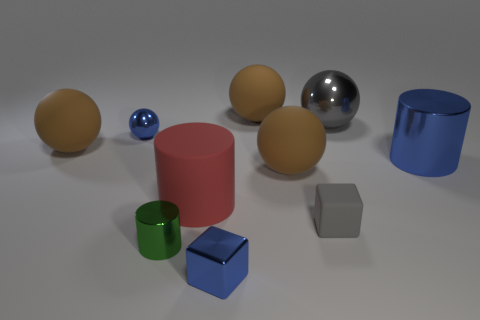There is a large cylinder in front of the cylinder that is to the right of the tiny gray rubber block; is there a large thing that is behind it?
Your answer should be very brief. Yes. What material is the green object?
Offer a terse response. Metal. How many other things are the same shape as the green metallic object?
Provide a short and direct response. 2. Do the small green shiny thing and the red matte thing have the same shape?
Provide a short and direct response. Yes. What number of objects are either shiny balls to the right of the red rubber object or matte spheres to the right of the small green thing?
Your answer should be very brief. 3. How many things are large gray metal balls or blue cylinders?
Make the answer very short. 2. There is a small blue shiny block that is to the right of the small green cylinder; what number of large balls are left of it?
Provide a succinct answer. 1. What number of other things are the same size as the red thing?
Your response must be concise. 5. There is a cube that is the same color as the tiny ball; what size is it?
Your response must be concise. Small. Do the big blue metal object right of the tiny blue block and the small green thing have the same shape?
Make the answer very short. Yes. 